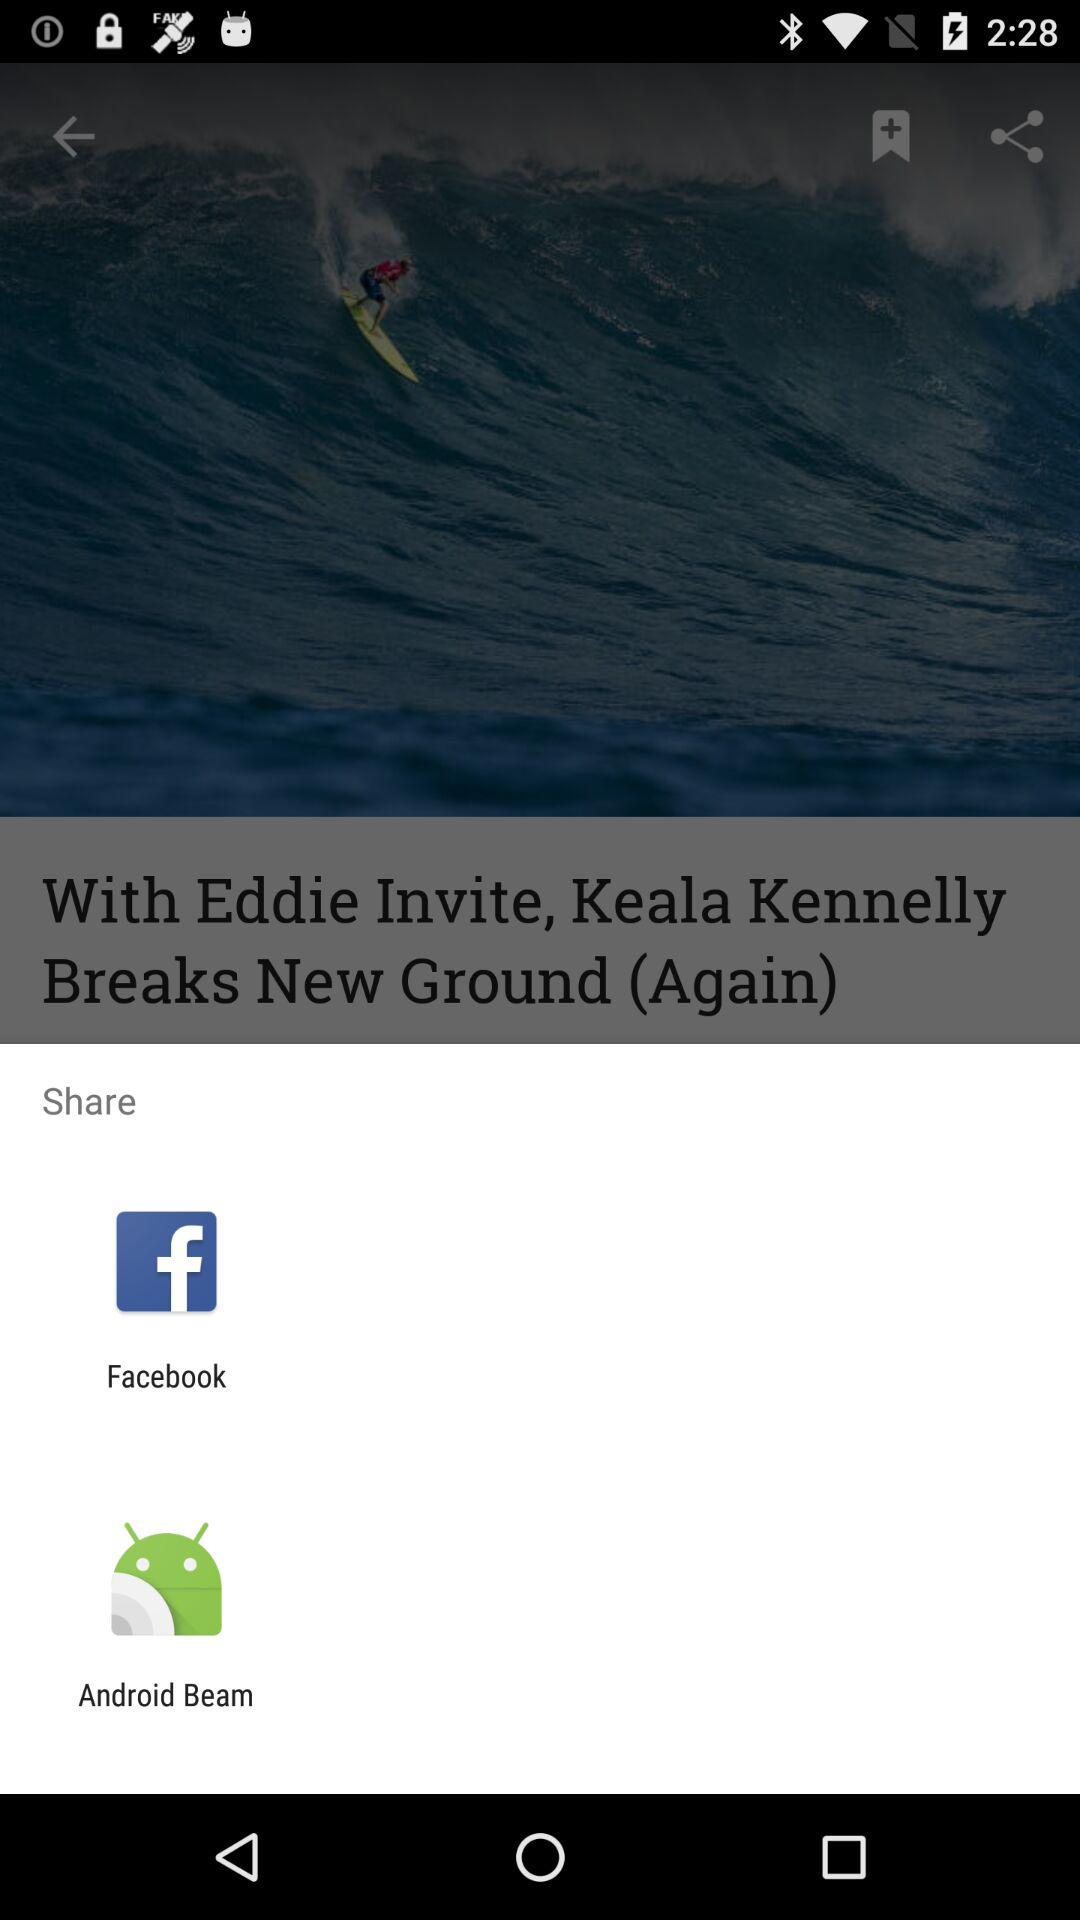What are the different options available for sharing? The different options available for sharing are "Facebook" and "Android Beam". 